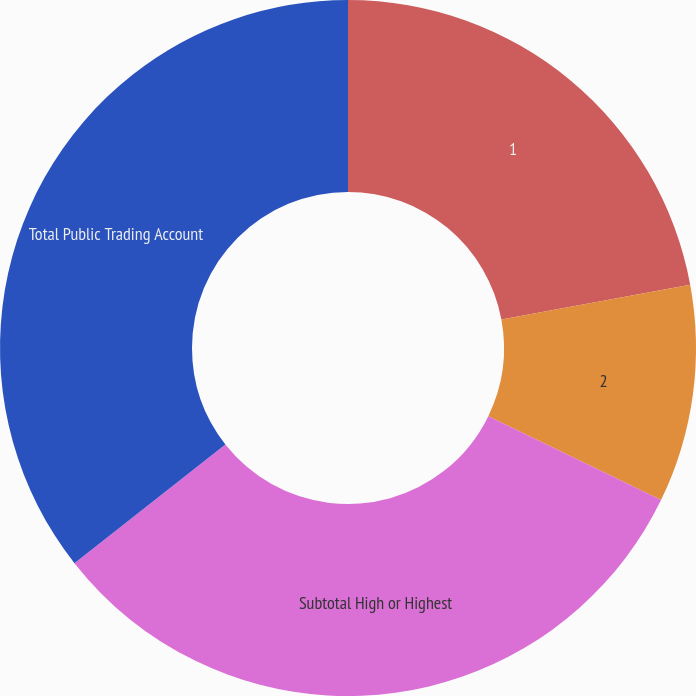Convert chart to OTSL. <chart><loc_0><loc_0><loc_500><loc_500><pie_chart><fcel>1<fcel>2<fcel>Subtotal High or Highest<fcel>Total Public Trading Account<nl><fcel>22.09%<fcel>10.11%<fcel>32.2%<fcel>35.61%<nl></chart> 